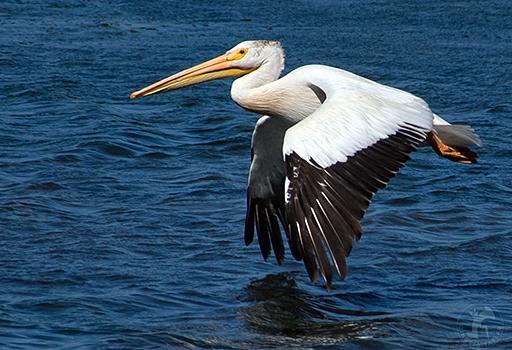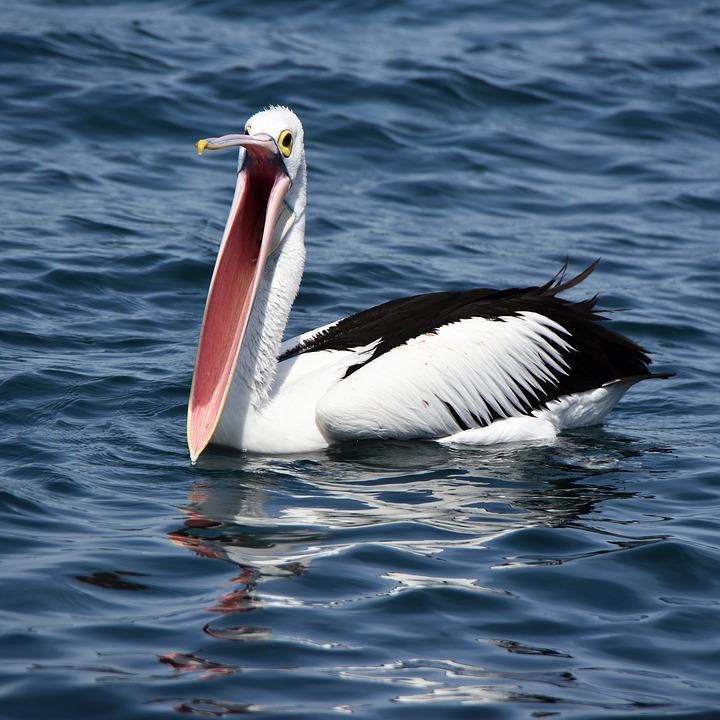The first image is the image on the left, the second image is the image on the right. Given the left and right images, does the statement "One image includes a pelican with it's beak open wide." hold true? Answer yes or no. Yes. The first image is the image on the left, the second image is the image on the right. Evaluate the accuracy of this statement regarding the images: "One of the pelicans is flying.". Is it true? Answer yes or no. Yes. 